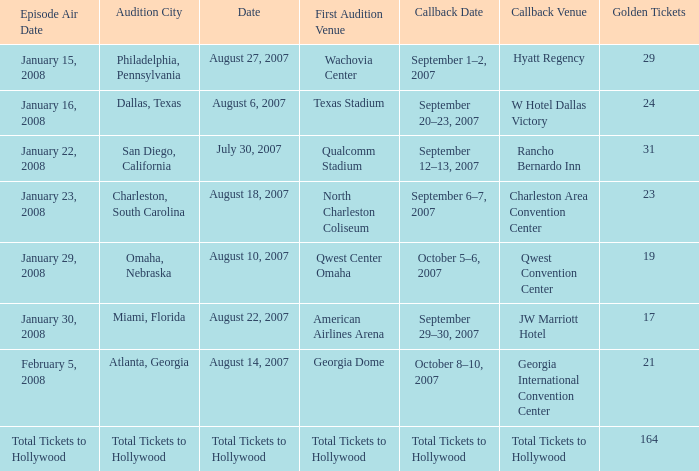What audition city has a Callback Date of october 5–6, 2007? Omaha, Nebraska. 